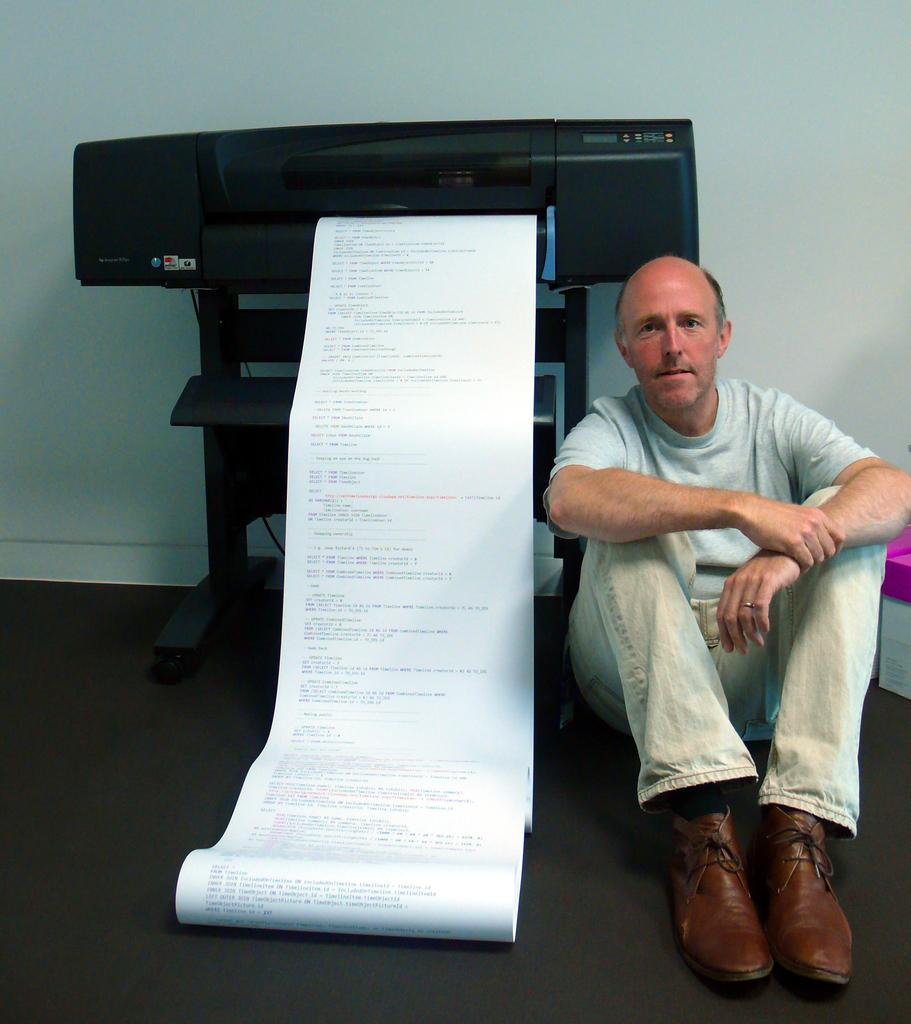What is the man in the image doing? The man is sitting on the floor. What can be seen near the man? There is a printing machine with paper near the man. What is visible in the background of the image? There is a wall in the background of the image. Can you see any skate marks on the floor in the image? There are no skate marks visible on the floor in the image. 